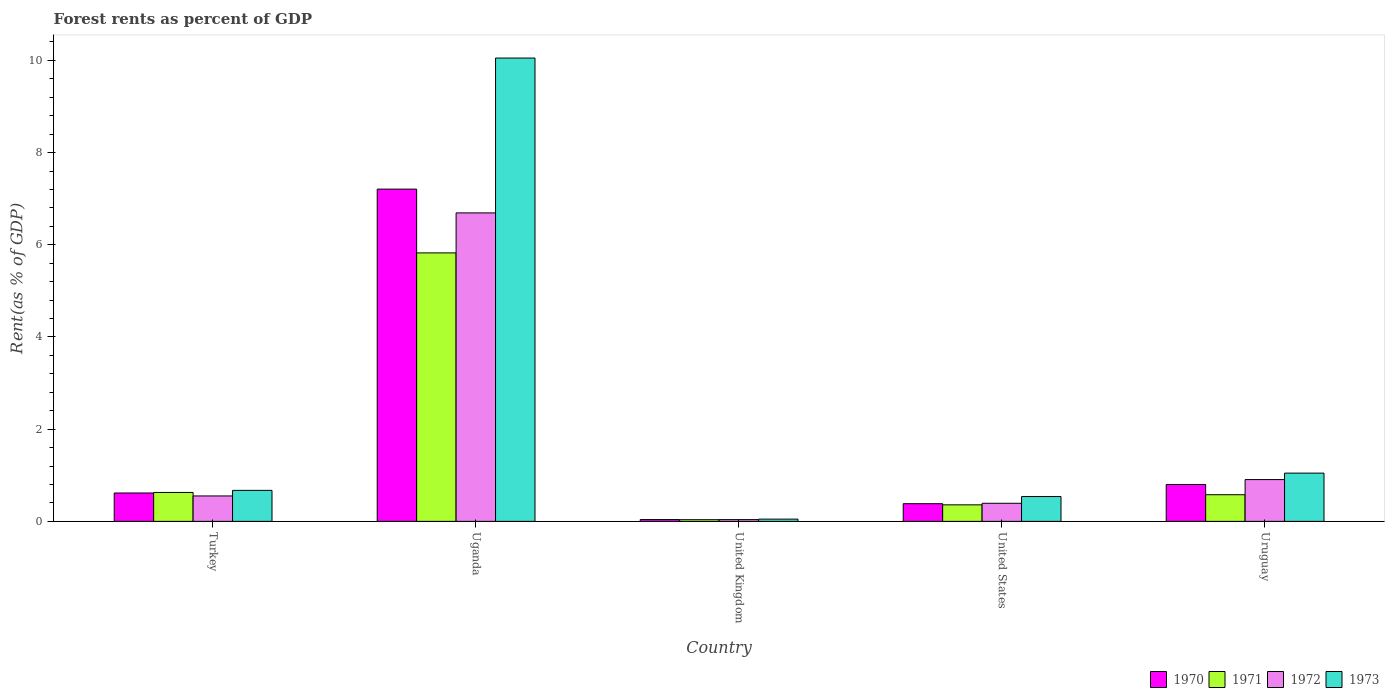How many groups of bars are there?
Offer a terse response. 5. Are the number of bars on each tick of the X-axis equal?
Offer a terse response. Yes. How many bars are there on the 3rd tick from the right?
Offer a terse response. 4. What is the label of the 4th group of bars from the left?
Your response must be concise. United States. What is the forest rent in 1970 in Uganda?
Your answer should be compact. 7.21. Across all countries, what is the maximum forest rent in 1970?
Your answer should be compact. 7.21. Across all countries, what is the minimum forest rent in 1971?
Give a very brief answer. 0.04. In which country was the forest rent in 1972 maximum?
Keep it short and to the point. Uganda. What is the total forest rent in 1971 in the graph?
Offer a very short reply. 7.42. What is the difference between the forest rent in 1970 in United Kingdom and that in United States?
Offer a very short reply. -0.34. What is the difference between the forest rent in 1972 in United States and the forest rent in 1971 in Turkey?
Offer a very short reply. -0.24. What is the average forest rent in 1971 per country?
Give a very brief answer. 1.48. What is the difference between the forest rent of/in 1973 and forest rent of/in 1970 in United States?
Offer a terse response. 0.16. What is the ratio of the forest rent in 1971 in Uganda to that in Uruguay?
Your answer should be very brief. 10.08. Is the difference between the forest rent in 1973 in United States and Uruguay greater than the difference between the forest rent in 1970 in United States and Uruguay?
Ensure brevity in your answer.  No. What is the difference between the highest and the second highest forest rent in 1970?
Make the answer very short. 0.18. What is the difference between the highest and the lowest forest rent in 1972?
Keep it short and to the point. 6.65. In how many countries, is the forest rent in 1972 greater than the average forest rent in 1972 taken over all countries?
Provide a short and direct response. 1. Is it the case that in every country, the sum of the forest rent in 1972 and forest rent in 1970 is greater than the sum of forest rent in 1971 and forest rent in 1973?
Ensure brevity in your answer.  No. What does the 2nd bar from the left in United Kingdom represents?
Your response must be concise. 1971. What does the 3rd bar from the right in Uruguay represents?
Offer a very short reply. 1971. How many bars are there?
Offer a terse response. 20. What is the difference between two consecutive major ticks on the Y-axis?
Provide a short and direct response. 2. Are the values on the major ticks of Y-axis written in scientific E-notation?
Keep it short and to the point. No. Does the graph contain any zero values?
Ensure brevity in your answer.  No. Where does the legend appear in the graph?
Keep it short and to the point. Bottom right. How many legend labels are there?
Give a very brief answer. 4. What is the title of the graph?
Provide a succinct answer. Forest rents as percent of GDP. What is the label or title of the Y-axis?
Make the answer very short. Rent(as % of GDP). What is the Rent(as % of GDP) of 1970 in Turkey?
Give a very brief answer. 0.62. What is the Rent(as % of GDP) in 1971 in Turkey?
Make the answer very short. 0.63. What is the Rent(as % of GDP) of 1972 in Turkey?
Keep it short and to the point. 0.55. What is the Rent(as % of GDP) of 1973 in Turkey?
Your answer should be compact. 0.67. What is the Rent(as % of GDP) in 1970 in Uganda?
Give a very brief answer. 7.21. What is the Rent(as % of GDP) of 1971 in Uganda?
Keep it short and to the point. 5.82. What is the Rent(as % of GDP) of 1972 in Uganda?
Keep it short and to the point. 6.69. What is the Rent(as % of GDP) of 1973 in Uganda?
Provide a succinct answer. 10.05. What is the Rent(as % of GDP) in 1970 in United Kingdom?
Ensure brevity in your answer.  0.04. What is the Rent(as % of GDP) in 1971 in United Kingdom?
Your answer should be compact. 0.04. What is the Rent(as % of GDP) in 1972 in United Kingdom?
Make the answer very short. 0.04. What is the Rent(as % of GDP) in 1973 in United Kingdom?
Give a very brief answer. 0.05. What is the Rent(as % of GDP) in 1970 in United States?
Offer a terse response. 0.38. What is the Rent(as % of GDP) of 1971 in United States?
Give a very brief answer. 0.36. What is the Rent(as % of GDP) in 1972 in United States?
Ensure brevity in your answer.  0.39. What is the Rent(as % of GDP) in 1973 in United States?
Provide a succinct answer. 0.54. What is the Rent(as % of GDP) of 1970 in Uruguay?
Give a very brief answer. 0.8. What is the Rent(as % of GDP) in 1971 in Uruguay?
Your response must be concise. 0.58. What is the Rent(as % of GDP) of 1972 in Uruguay?
Your answer should be compact. 0.91. What is the Rent(as % of GDP) of 1973 in Uruguay?
Provide a short and direct response. 1.05. Across all countries, what is the maximum Rent(as % of GDP) of 1970?
Provide a short and direct response. 7.21. Across all countries, what is the maximum Rent(as % of GDP) of 1971?
Provide a succinct answer. 5.82. Across all countries, what is the maximum Rent(as % of GDP) of 1972?
Offer a terse response. 6.69. Across all countries, what is the maximum Rent(as % of GDP) in 1973?
Your answer should be compact. 10.05. Across all countries, what is the minimum Rent(as % of GDP) of 1970?
Provide a short and direct response. 0.04. Across all countries, what is the minimum Rent(as % of GDP) of 1971?
Your response must be concise. 0.04. Across all countries, what is the minimum Rent(as % of GDP) in 1972?
Give a very brief answer. 0.04. Across all countries, what is the minimum Rent(as % of GDP) of 1973?
Provide a succinct answer. 0.05. What is the total Rent(as % of GDP) of 1970 in the graph?
Ensure brevity in your answer.  9.04. What is the total Rent(as % of GDP) in 1971 in the graph?
Keep it short and to the point. 7.42. What is the total Rent(as % of GDP) of 1972 in the graph?
Provide a short and direct response. 8.58. What is the total Rent(as % of GDP) in 1973 in the graph?
Keep it short and to the point. 12.36. What is the difference between the Rent(as % of GDP) in 1970 in Turkey and that in Uganda?
Provide a succinct answer. -6.59. What is the difference between the Rent(as % of GDP) in 1971 in Turkey and that in Uganda?
Offer a very short reply. -5.2. What is the difference between the Rent(as % of GDP) in 1972 in Turkey and that in Uganda?
Your answer should be compact. -6.14. What is the difference between the Rent(as % of GDP) in 1973 in Turkey and that in Uganda?
Your response must be concise. -9.38. What is the difference between the Rent(as % of GDP) of 1970 in Turkey and that in United Kingdom?
Keep it short and to the point. 0.58. What is the difference between the Rent(as % of GDP) of 1971 in Turkey and that in United Kingdom?
Keep it short and to the point. 0.59. What is the difference between the Rent(as % of GDP) of 1972 in Turkey and that in United Kingdom?
Make the answer very short. 0.51. What is the difference between the Rent(as % of GDP) of 1973 in Turkey and that in United Kingdom?
Make the answer very short. 0.62. What is the difference between the Rent(as % of GDP) of 1970 in Turkey and that in United States?
Your response must be concise. 0.23. What is the difference between the Rent(as % of GDP) of 1971 in Turkey and that in United States?
Your response must be concise. 0.27. What is the difference between the Rent(as % of GDP) of 1972 in Turkey and that in United States?
Provide a succinct answer. 0.16. What is the difference between the Rent(as % of GDP) of 1973 in Turkey and that in United States?
Offer a very short reply. 0.13. What is the difference between the Rent(as % of GDP) in 1970 in Turkey and that in Uruguay?
Offer a very short reply. -0.18. What is the difference between the Rent(as % of GDP) of 1971 in Turkey and that in Uruguay?
Your answer should be compact. 0.05. What is the difference between the Rent(as % of GDP) of 1972 in Turkey and that in Uruguay?
Provide a succinct answer. -0.35. What is the difference between the Rent(as % of GDP) of 1973 in Turkey and that in Uruguay?
Your answer should be compact. -0.37. What is the difference between the Rent(as % of GDP) in 1970 in Uganda and that in United Kingdom?
Give a very brief answer. 7.17. What is the difference between the Rent(as % of GDP) of 1971 in Uganda and that in United Kingdom?
Your response must be concise. 5.79. What is the difference between the Rent(as % of GDP) in 1972 in Uganda and that in United Kingdom?
Provide a short and direct response. 6.65. What is the difference between the Rent(as % of GDP) of 1973 in Uganda and that in United Kingdom?
Provide a succinct answer. 10. What is the difference between the Rent(as % of GDP) of 1970 in Uganda and that in United States?
Ensure brevity in your answer.  6.82. What is the difference between the Rent(as % of GDP) of 1971 in Uganda and that in United States?
Offer a terse response. 5.47. What is the difference between the Rent(as % of GDP) in 1972 in Uganda and that in United States?
Offer a terse response. 6.3. What is the difference between the Rent(as % of GDP) of 1973 in Uganda and that in United States?
Make the answer very short. 9.51. What is the difference between the Rent(as % of GDP) in 1970 in Uganda and that in Uruguay?
Provide a succinct answer. 6.41. What is the difference between the Rent(as % of GDP) in 1971 in Uganda and that in Uruguay?
Offer a terse response. 5.25. What is the difference between the Rent(as % of GDP) of 1972 in Uganda and that in Uruguay?
Keep it short and to the point. 5.79. What is the difference between the Rent(as % of GDP) in 1973 in Uganda and that in Uruguay?
Give a very brief answer. 9. What is the difference between the Rent(as % of GDP) in 1970 in United Kingdom and that in United States?
Your answer should be very brief. -0.34. What is the difference between the Rent(as % of GDP) of 1971 in United Kingdom and that in United States?
Give a very brief answer. -0.32. What is the difference between the Rent(as % of GDP) in 1972 in United Kingdom and that in United States?
Your response must be concise. -0.35. What is the difference between the Rent(as % of GDP) of 1973 in United Kingdom and that in United States?
Offer a very short reply. -0.49. What is the difference between the Rent(as % of GDP) in 1970 in United Kingdom and that in Uruguay?
Offer a terse response. -0.76. What is the difference between the Rent(as % of GDP) in 1971 in United Kingdom and that in Uruguay?
Your response must be concise. -0.54. What is the difference between the Rent(as % of GDP) in 1972 in United Kingdom and that in Uruguay?
Ensure brevity in your answer.  -0.87. What is the difference between the Rent(as % of GDP) in 1973 in United Kingdom and that in Uruguay?
Your answer should be very brief. -1. What is the difference between the Rent(as % of GDP) in 1970 in United States and that in Uruguay?
Ensure brevity in your answer.  -0.42. What is the difference between the Rent(as % of GDP) of 1971 in United States and that in Uruguay?
Give a very brief answer. -0.22. What is the difference between the Rent(as % of GDP) of 1972 in United States and that in Uruguay?
Provide a short and direct response. -0.51. What is the difference between the Rent(as % of GDP) of 1973 in United States and that in Uruguay?
Offer a very short reply. -0.51. What is the difference between the Rent(as % of GDP) of 1970 in Turkey and the Rent(as % of GDP) of 1971 in Uganda?
Provide a short and direct response. -5.21. What is the difference between the Rent(as % of GDP) in 1970 in Turkey and the Rent(as % of GDP) in 1972 in Uganda?
Keep it short and to the point. -6.08. What is the difference between the Rent(as % of GDP) of 1970 in Turkey and the Rent(as % of GDP) of 1973 in Uganda?
Your answer should be compact. -9.44. What is the difference between the Rent(as % of GDP) in 1971 in Turkey and the Rent(as % of GDP) in 1972 in Uganda?
Your answer should be compact. -6.06. What is the difference between the Rent(as % of GDP) in 1971 in Turkey and the Rent(as % of GDP) in 1973 in Uganda?
Give a very brief answer. -9.42. What is the difference between the Rent(as % of GDP) of 1972 in Turkey and the Rent(as % of GDP) of 1973 in Uganda?
Your answer should be very brief. -9.5. What is the difference between the Rent(as % of GDP) of 1970 in Turkey and the Rent(as % of GDP) of 1971 in United Kingdom?
Provide a short and direct response. 0.58. What is the difference between the Rent(as % of GDP) of 1970 in Turkey and the Rent(as % of GDP) of 1972 in United Kingdom?
Make the answer very short. 0.58. What is the difference between the Rent(as % of GDP) of 1970 in Turkey and the Rent(as % of GDP) of 1973 in United Kingdom?
Offer a terse response. 0.57. What is the difference between the Rent(as % of GDP) of 1971 in Turkey and the Rent(as % of GDP) of 1972 in United Kingdom?
Offer a terse response. 0.59. What is the difference between the Rent(as % of GDP) of 1971 in Turkey and the Rent(as % of GDP) of 1973 in United Kingdom?
Offer a terse response. 0.58. What is the difference between the Rent(as % of GDP) of 1972 in Turkey and the Rent(as % of GDP) of 1973 in United Kingdom?
Provide a succinct answer. 0.5. What is the difference between the Rent(as % of GDP) of 1970 in Turkey and the Rent(as % of GDP) of 1971 in United States?
Your response must be concise. 0.26. What is the difference between the Rent(as % of GDP) in 1970 in Turkey and the Rent(as % of GDP) in 1972 in United States?
Your answer should be very brief. 0.22. What is the difference between the Rent(as % of GDP) of 1970 in Turkey and the Rent(as % of GDP) of 1973 in United States?
Give a very brief answer. 0.08. What is the difference between the Rent(as % of GDP) of 1971 in Turkey and the Rent(as % of GDP) of 1972 in United States?
Provide a succinct answer. 0.23. What is the difference between the Rent(as % of GDP) in 1971 in Turkey and the Rent(as % of GDP) in 1973 in United States?
Offer a terse response. 0.09. What is the difference between the Rent(as % of GDP) of 1972 in Turkey and the Rent(as % of GDP) of 1973 in United States?
Offer a very short reply. 0.01. What is the difference between the Rent(as % of GDP) in 1970 in Turkey and the Rent(as % of GDP) in 1971 in Uruguay?
Give a very brief answer. 0.04. What is the difference between the Rent(as % of GDP) in 1970 in Turkey and the Rent(as % of GDP) in 1972 in Uruguay?
Offer a very short reply. -0.29. What is the difference between the Rent(as % of GDP) in 1970 in Turkey and the Rent(as % of GDP) in 1973 in Uruguay?
Your answer should be compact. -0.43. What is the difference between the Rent(as % of GDP) in 1971 in Turkey and the Rent(as % of GDP) in 1972 in Uruguay?
Provide a short and direct response. -0.28. What is the difference between the Rent(as % of GDP) in 1971 in Turkey and the Rent(as % of GDP) in 1973 in Uruguay?
Ensure brevity in your answer.  -0.42. What is the difference between the Rent(as % of GDP) of 1972 in Turkey and the Rent(as % of GDP) of 1973 in Uruguay?
Provide a short and direct response. -0.49. What is the difference between the Rent(as % of GDP) of 1970 in Uganda and the Rent(as % of GDP) of 1971 in United Kingdom?
Ensure brevity in your answer.  7.17. What is the difference between the Rent(as % of GDP) in 1970 in Uganda and the Rent(as % of GDP) in 1972 in United Kingdom?
Ensure brevity in your answer.  7.17. What is the difference between the Rent(as % of GDP) in 1970 in Uganda and the Rent(as % of GDP) in 1973 in United Kingdom?
Keep it short and to the point. 7.16. What is the difference between the Rent(as % of GDP) of 1971 in Uganda and the Rent(as % of GDP) of 1972 in United Kingdom?
Give a very brief answer. 5.79. What is the difference between the Rent(as % of GDP) in 1971 in Uganda and the Rent(as % of GDP) in 1973 in United Kingdom?
Offer a terse response. 5.78. What is the difference between the Rent(as % of GDP) in 1972 in Uganda and the Rent(as % of GDP) in 1973 in United Kingdom?
Make the answer very short. 6.64. What is the difference between the Rent(as % of GDP) in 1970 in Uganda and the Rent(as % of GDP) in 1971 in United States?
Give a very brief answer. 6.85. What is the difference between the Rent(as % of GDP) in 1970 in Uganda and the Rent(as % of GDP) in 1972 in United States?
Your answer should be very brief. 6.81. What is the difference between the Rent(as % of GDP) of 1970 in Uganda and the Rent(as % of GDP) of 1973 in United States?
Provide a succinct answer. 6.67. What is the difference between the Rent(as % of GDP) in 1971 in Uganda and the Rent(as % of GDP) in 1972 in United States?
Provide a succinct answer. 5.43. What is the difference between the Rent(as % of GDP) in 1971 in Uganda and the Rent(as % of GDP) in 1973 in United States?
Offer a very short reply. 5.29. What is the difference between the Rent(as % of GDP) in 1972 in Uganda and the Rent(as % of GDP) in 1973 in United States?
Offer a terse response. 6.15. What is the difference between the Rent(as % of GDP) of 1970 in Uganda and the Rent(as % of GDP) of 1971 in Uruguay?
Give a very brief answer. 6.63. What is the difference between the Rent(as % of GDP) in 1970 in Uganda and the Rent(as % of GDP) in 1972 in Uruguay?
Your answer should be very brief. 6.3. What is the difference between the Rent(as % of GDP) of 1970 in Uganda and the Rent(as % of GDP) of 1973 in Uruguay?
Provide a succinct answer. 6.16. What is the difference between the Rent(as % of GDP) in 1971 in Uganda and the Rent(as % of GDP) in 1972 in Uruguay?
Keep it short and to the point. 4.92. What is the difference between the Rent(as % of GDP) of 1971 in Uganda and the Rent(as % of GDP) of 1973 in Uruguay?
Your response must be concise. 4.78. What is the difference between the Rent(as % of GDP) of 1972 in Uganda and the Rent(as % of GDP) of 1973 in Uruguay?
Provide a short and direct response. 5.65. What is the difference between the Rent(as % of GDP) of 1970 in United Kingdom and the Rent(as % of GDP) of 1971 in United States?
Provide a succinct answer. -0.32. What is the difference between the Rent(as % of GDP) in 1970 in United Kingdom and the Rent(as % of GDP) in 1972 in United States?
Make the answer very short. -0.35. What is the difference between the Rent(as % of GDP) in 1970 in United Kingdom and the Rent(as % of GDP) in 1973 in United States?
Your response must be concise. -0.5. What is the difference between the Rent(as % of GDP) of 1971 in United Kingdom and the Rent(as % of GDP) of 1972 in United States?
Give a very brief answer. -0.36. What is the difference between the Rent(as % of GDP) of 1971 in United Kingdom and the Rent(as % of GDP) of 1973 in United States?
Give a very brief answer. -0.5. What is the difference between the Rent(as % of GDP) of 1972 in United Kingdom and the Rent(as % of GDP) of 1973 in United States?
Your answer should be compact. -0.5. What is the difference between the Rent(as % of GDP) of 1970 in United Kingdom and the Rent(as % of GDP) of 1971 in Uruguay?
Provide a succinct answer. -0.54. What is the difference between the Rent(as % of GDP) of 1970 in United Kingdom and the Rent(as % of GDP) of 1972 in Uruguay?
Your response must be concise. -0.87. What is the difference between the Rent(as % of GDP) of 1970 in United Kingdom and the Rent(as % of GDP) of 1973 in Uruguay?
Your answer should be compact. -1.01. What is the difference between the Rent(as % of GDP) in 1971 in United Kingdom and the Rent(as % of GDP) in 1972 in Uruguay?
Your answer should be compact. -0.87. What is the difference between the Rent(as % of GDP) of 1971 in United Kingdom and the Rent(as % of GDP) of 1973 in Uruguay?
Provide a succinct answer. -1.01. What is the difference between the Rent(as % of GDP) in 1972 in United Kingdom and the Rent(as % of GDP) in 1973 in Uruguay?
Provide a short and direct response. -1.01. What is the difference between the Rent(as % of GDP) in 1970 in United States and the Rent(as % of GDP) in 1971 in Uruguay?
Provide a short and direct response. -0.19. What is the difference between the Rent(as % of GDP) of 1970 in United States and the Rent(as % of GDP) of 1972 in Uruguay?
Your answer should be very brief. -0.52. What is the difference between the Rent(as % of GDP) in 1970 in United States and the Rent(as % of GDP) in 1973 in Uruguay?
Make the answer very short. -0.66. What is the difference between the Rent(as % of GDP) of 1971 in United States and the Rent(as % of GDP) of 1972 in Uruguay?
Provide a short and direct response. -0.55. What is the difference between the Rent(as % of GDP) in 1971 in United States and the Rent(as % of GDP) in 1973 in Uruguay?
Offer a terse response. -0.69. What is the difference between the Rent(as % of GDP) in 1972 in United States and the Rent(as % of GDP) in 1973 in Uruguay?
Give a very brief answer. -0.65. What is the average Rent(as % of GDP) in 1970 per country?
Your response must be concise. 1.81. What is the average Rent(as % of GDP) in 1971 per country?
Your answer should be compact. 1.48. What is the average Rent(as % of GDP) in 1972 per country?
Ensure brevity in your answer.  1.72. What is the average Rent(as % of GDP) in 1973 per country?
Your answer should be very brief. 2.47. What is the difference between the Rent(as % of GDP) of 1970 and Rent(as % of GDP) of 1971 in Turkey?
Offer a terse response. -0.01. What is the difference between the Rent(as % of GDP) in 1970 and Rent(as % of GDP) in 1972 in Turkey?
Keep it short and to the point. 0.06. What is the difference between the Rent(as % of GDP) of 1970 and Rent(as % of GDP) of 1973 in Turkey?
Your response must be concise. -0.06. What is the difference between the Rent(as % of GDP) in 1971 and Rent(as % of GDP) in 1972 in Turkey?
Offer a very short reply. 0.08. What is the difference between the Rent(as % of GDP) of 1971 and Rent(as % of GDP) of 1973 in Turkey?
Your answer should be very brief. -0.05. What is the difference between the Rent(as % of GDP) of 1972 and Rent(as % of GDP) of 1973 in Turkey?
Offer a terse response. -0.12. What is the difference between the Rent(as % of GDP) in 1970 and Rent(as % of GDP) in 1971 in Uganda?
Offer a terse response. 1.38. What is the difference between the Rent(as % of GDP) in 1970 and Rent(as % of GDP) in 1972 in Uganda?
Offer a terse response. 0.52. What is the difference between the Rent(as % of GDP) of 1970 and Rent(as % of GDP) of 1973 in Uganda?
Ensure brevity in your answer.  -2.84. What is the difference between the Rent(as % of GDP) of 1971 and Rent(as % of GDP) of 1972 in Uganda?
Your answer should be compact. -0.87. What is the difference between the Rent(as % of GDP) of 1971 and Rent(as % of GDP) of 1973 in Uganda?
Offer a terse response. -4.23. What is the difference between the Rent(as % of GDP) of 1972 and Rent(as % of GDP) of 1973 in Uganda?
Your answer should be compact. -3.36. What is the difference between the Rent(as % of GDP) in 1970 and Rent(as % of GDP) in 1971 in United Kingdom?
Your answer should be very brief. 0. What is the difference between the Rent(as % of GDP) of 1970 and Rent(as % of GDP) of 1972 in United Kingdom?
Provide a short and direct response. 0. What is the difference between the Rent(as % of GDP) of 1970 and Rent(as % of GDP) of 1973 in United Kingdom?
Keep it short and to the point. -0.01. What is the difference between the Rent(as % of GDP) of 1971 and Rent(as % of GDP) of 1972 in United Kingdom?
Make the answer very short. -0. What is the difference between the Rent(as % of GDP) of 1971 and Rent(as % of GDP) of 1973 in United Kingdom?
Your answer should be very brief. -0.01. What is the difference between the Rent(as % of GDP) of 1972 and Rent(as % of GDP) of 1973 in United Kingdom?
Provide a succinct answer. -0.01. What is the difference between the Rent(as % of GDP) of 1970 and Rent(as % of GDP) of 1971 in United States?
Your response must be concise. 0.02. What is the difference between the Rent(as % of GDP) in 1970 and Rent(as % of GDP) in 1972 in United States?
Your response must be concise. -0.01. What is the difference between the Rent(as % of GDP) in 1970 and Rent(as % of GDP) in 1973 in United States?
Give a very brief answer. -0.16. What is the difference between the Rent(as % of GDP) in 1971 and Rent(as % of GDP) in 1972 in United States?
Make the answer very short. -0.03. What is the difference between the Rent(as % of GDP) of 1971 and Rent(as % of GDP) of 1973 in United States?
Provide a short and direct response. -0.18. What is the difference between the Rent(as % of GDP) of 1972 and Rent(as % of GDP) of 1973 in United States?
Ensure brevity in your answer.  -0.15. What is the difference between the Rent(as % of GDP) in 1970 and Rent(as % of GDP) in 1971 in Uruguay?
Your answer should be very brief. 0.22. What is the difference between the Rent(as % of GDP) in 1970 and Rent(as % of GDP) in 1972 in Uruguay?
Provide a succinct answer. -0.11. What is the difference between the Rent(as % of GDP) of 1970 and Rent(as % of GDP) of 1973 in Uruguay?
Provide a short and direct response. -0.25. What is the difference between the Rent(as % of GDP) of 1971 and Rent(as % of GDP) of 1972 in Uruguay?
Your answer should be very brief. -0.33. What is the difference between the Rent(as % of GDP) of 1971 and Rent(as % of GDP) of 1973 in Uruguay?
Offer a very short reply. -0.47. What is the difference between the Rent(as % of GDP) in 1972 and Rent(as % of GDP) in 1973 in Uruguay?
Provide a succinct answer. -0.14. What is the ratio of the Rent(as % of GDP) in 1970 in Turkey to that in Uganda?
Provide a short and direct response. 0.09. What is the ratio of the Rent(as % of GDP) of 1971 in Turkey to that in Uganda?
Provide a short and direct response. 0.11. What is the ratio of the Rent(as % of GDP) in 1972 in Turkey to that in Uganda?
Provide a succinct answer. 0.08. What is the ratio of the Rent(as % of GDP) of 1973 in Turkey to that in Uganda?
Offer a very short reply. 0.07. What is the ratio of the Rent(as % of GDP) of 1970 in Turkey to that in United Kingdom?
Offer a very short reply. 15.78. What is the ratio of the Rent(as % of GDP) of 1971 in Turkey to that in United Kingdom?
Keep it short and to the point. 17.29. What is the ratio of the Rent(as % of GDP) in 1972 in Turkey to that in United Kingdom?
Offer a very short reply. 14.49. What is the ratio of the Rent(as % of GDP) of 1973 in Turkey to that in United Kingdom?
Your response must be concise. 13.83. What is the ratio of the Rent(as % of GDP) in 1970 in Turkey to that in United States?
Offer a terse response. 1.61. What is the ratio of the Rent(as % of GDP) of 1971 in Turkey to that in United States?
Make the answer very short. 1.75. What is the ratio of the Rent(as % of GDP) of 1972 in Turkey to that in United States?
Ensure brevity in your answer.  1.41. What is the ratio of the Rent(as % of GDP) in 1973 in Turkey to that in United States?
Provide a succinct answer. 1.25. What is the ratio of the Rent(as % of GDP) of 1970 in Turkey to that in Uruguay?
Your answer should be very brief. 0.77. What is the ratio of the Rent(as % of GDP) in 1971 in Turkey to that in Uruguay?
Offer a terse response. 1.09. What is the ratio of the Rent(as % of GDP) in 1972 in Turkey to that in Uruguay?
Provide a short and direct response. 0.61. What is the ratio of the Rent(as % of GDP) in 1973 in Turkey to that in Uruguay?
Your answer should be compact. 0.64. What is the ratio of the Rent(as % of GDP) of 1970 in Uganda to that in United Kingdom?
Provide a short and direct response. 184.81. What is the ratio of the Rent(as % of GDP) of 1971 in Uganda to that in United Kingdom?
Offer a terse response. 160.46. What is the ratio of the Rent(as % of GDP) of 1972 in Uganda to that in United Kingdom?
Keep it short and to the point. 175.86. What is the ratio of the Rent(as % of GDP) of 1973 in Uganda to that in United Kingdom?
Offer a very short reply. 206.75. What is the ratio of the Rent(as % of GDP) in 1970 in Uganda to that in United States?
Offer a terse response. 18.8. What is the ratio of the Rent(as % of GDP) in 1971 in Uganda to that in United States?
Your answer should be very brief. 16.24. What is the ratio of the Rent(as % of GDP) of 1972 in Uganda to that in United States?
Keep it short and to the point. 17.05. What is the ratio of the Rent(as % of GDP) of 1973 in Uganda to that in United States?
Your response must be concise. 18.66. What is the ratio of the Rent(as % of GDP) in 1970 in Uganda to that in Uruguay?
Your answer should be compact. 9.01. What is the ratio of the Rent(as % of GDP) of 1971 in Uganda to that in Uruguay?
Offer a terse response. 10.08. What is the ratio of the Rent(as % of GDP) in 1972 in Uganda to that in Uruguay?
Offer a very short reply. 7.38. What is the ratio of the Rent(as % of GDP) of 1973 in Uganda to that in Uruguay?
Offer a very short reply. 9.6. What is the ratio of the Rent(as % of GDP) of 1970 in United Kingdom to that in United States?
Your response must be concise. 0.1. What is the ratio of the Rent(as % of GDP) in 1971 in United Kingdom to that in United States?
Ensure brevity in your answer.  0.1. What is the ratio of the Rent(as % of GDP) in 1972 in United Kingdom to that in United States?
Offer a terse response. 0.1. What is the ratio of the Rent(as % of GDP) of 1973 in United Kingdom to that in United States?
Your answer should be compact. 0.09. What is the ratio of the Rent(as % of GDP) of 1970 in United Kingdom to that in Uruguay?
Your response must be concise. 0.05. What is the ratio of the Rent(as % of GDP) of 1971 in United Kingdom to that in Uruguay?
Provide a succinct answer. 0.06. What is the ratio of the Rent(as % of GDP) of 1972 in United Kingdom to that in Uruguay?
Give a very brief answer. 0.04. What is the ratio of the Rent(as % of GDP) in 1973 in United Kingdom to that in Uruguay?
Ensure brevity in your answer.  0.05. What is the ratio of the Rent(as % of GDP) of 1970 in United States to that in Uruguay?
Provide a succinct answer. 0.48. What is the ratio of the Rent(as % of GDP) in 1971 in United States to that in Uruguay?
Provide a short and direct response. 0.62. What is the ratio of the Rent(as % of GDP) in 1972 in United States to that in Uruguay?
Make the answer very short. 0.43. What is the ratio of the Rent(as % of GDP) of 1973 in United States to that in Uruguay?
Make the answer very short. 0.51. What is the difference between the highest and the second highest Rent(as % of GDP) in 1970?
Your response must be concise. 6.41. What is the difference between the highest and the second highest Rent(as % of GDP) in 1971?
Offer a terse response. 5.2. What is the difference between the highest and the second highest Rent(as % of GDP) of 1972?
Give a very brief answer. 5.79. What is the difference between the highest and the second highest Rent(as % of GDP) of 1973?
Offer a very short reply. 9. What is the difference between the highest and the lowest Rent(as % of GDP) of 1970?
Provide a short and direct response. 7.17. What is the difference between the highest and the lowest Rent(as % of GDP) in 1971?
Keep it short and to the point. 5.79. What is the difference between the highest and the lowest Rent(as % of GDP) of 1972?
Give a very brief answer. 6.65. What is the difference between the highest and the lowest Rent(as % of GDP) of 1973?
Keep it short and to the point. 10. 